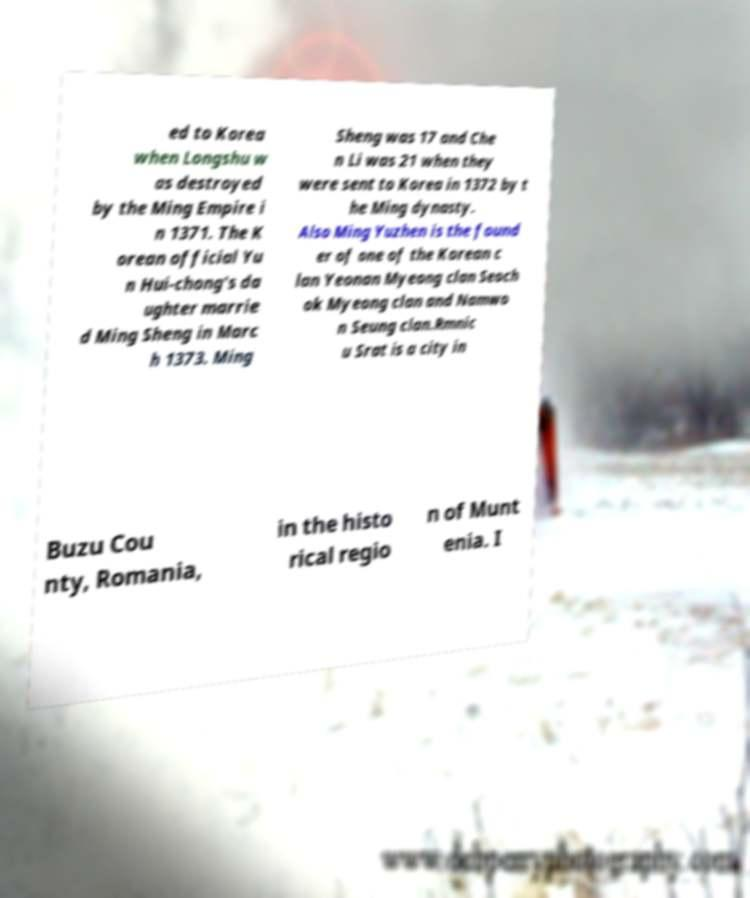Could you assist in decoding the text presented in this image and type it out clearly? ed to Korea when Longshu w as destroyed by the Ming Empire i n 1371. The K orean official Yu n Hui-chong's da ughter marrie d Ming Sheng in Marc h 1373. Ming Sheng was 17 and Che n Li was 21 when they were sent to Korea in 1372 by t he Ming dynasty. Also Ming Yuzhen is the found er of one of the Korean c lan Yeonan Myeong clan Seoch ok Myeong clan and Namwo n Seung clan.Rmnic u Srat is a city in Buzu Cou nty, Romania, in the histo rical regio n of Munt enia. I 